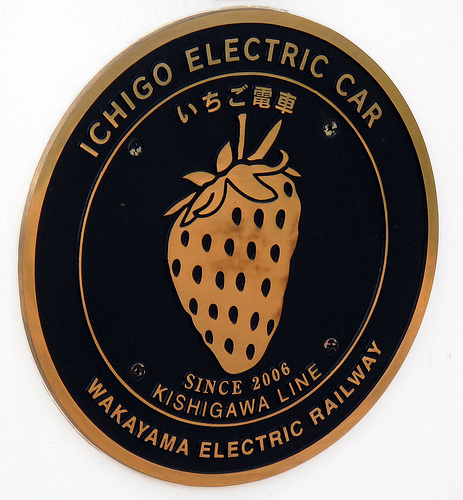<image>
Is there a sign in the wall? No. The sign is not contained within the wall. These objects have a different spatial relationship. 